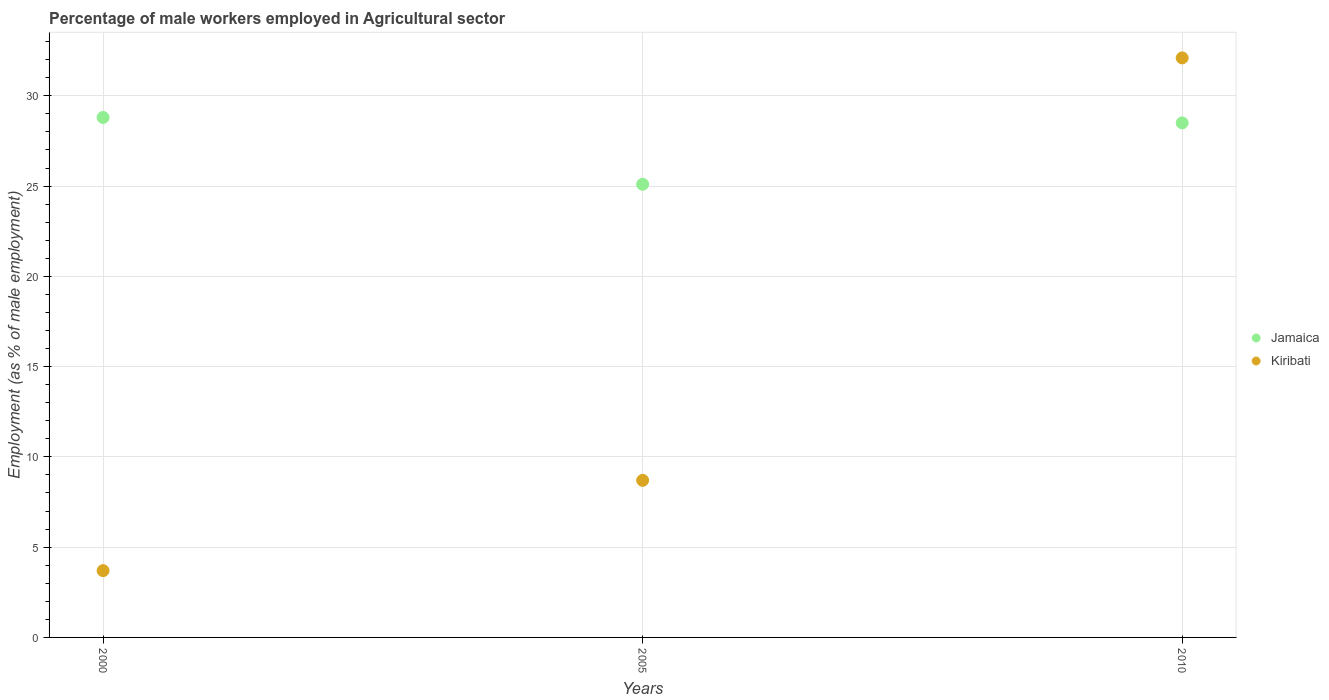Is the number of dotlines equal to the number of legend labels?
Give a very brief answer. Yes. What is the percentage of male workers employed in Agricultural sector in Kiribati in 2005?
Your answer should be compact. 8.7. Across all years, what is the maximum percentage of male workers employed in Agricultural sector in Kiribati?
Your answer should be very brief. 32.1. Across all years, what is the minimum percentage of male workers employed in Agricultural sector in Jamaica?
Your answer should be very brief. 25.1. In which year was the percentage of male workers employed in Agricultural sector in Jamaica maximum?
Provide a short and direct response. 2000. In which year was the percentage of male workers employed in Agricultural sector in Jamaica minimum?
Give a very brief answer. 2005. What is the total percentage of male workers employed in Agricultural sector in Jamaica in the graph?
Provide a short and direct response. 82.4. What is the difference between the percentage of male workers employed in Agricultural sector in Jamaica in 2000 and that in 2005?
Ensure brevity in your answer.  3.7. What is the difference between the percentage of male workers employed in Agricultural sector in Kiribati in 2005 and the percentage of male workers employed in Agricultural sector in Jamaica in 2000?
Offer a very short reply. -20.1. What is the average percentage of male workers employed in Agricultural sector in Kiribati per year?
Provide a short and direct response. 14.83. In the year 2000, what is the difference between the percentage of male workers employed in Agricultural sector in Kiribati and percentage of male workers employed in Agricultural sector in Jamaica?
Offer a very short reply. -25.1. In how many years, is the percentage of male workers employed in Agricultural sector in Kiribati greater than 2 %?
Keep it short and to the point. 3. What is the ratio of the percentage of male workers employed in Agricultural sector in Jamaica in 2000 to that in 2010?
Offer a terse response. 1.01. Is the percentage of male workers employed in Agricultural sector in Jamaica in 2000 less than that in 2005?
Provide a short and direct response. No. Is the difference between the percentage of male workers employed in Agricultural sector in Kiribati in 2005 and 2010 greater than the difference between the percentage of male workers employed in Agricultural sector in Jamaica in 2005 and 2010?
Make the answer very short. No. What is the difference between the highest and the second highest percentage of male workers employed in Agricultural sector in Jamaica?
Offer a very short reply. 0.3. What is the difference between the highest and the lowest percentage of male workers employed in Agricultural sector in Kiribati?
Give a very brief answer. 28.4. Is the percentage of male workers employed in Agricultural sector in Kiribati strictly less than the percentage of male workers employed in Agricultural sector in Jamaica over the years?
Your response must be concise. No. How many dotlines are there?
Keep it short and to the point. 2. What is the title of the graph?
Offer a terse response. Percentage of male workers employed in Agricultural sector. Does "Lebanon" appear as one of the legend labels in the graph?
Your answer should be very brief. No. What is the label or title of the X-axis?
Your answer should be very brief. Years. What is the label or title of the Y-axis?
Provide a short and direct response. Employment (as % of male employment). What is the Employment (as % of male employment) in Jamaica in 2000?
Your response must be concise. 28.8. What is the Employment (as % of male employment) of Kiribati in 2000?
Keep it short and to the point. 3.7. What is the Employment (as % of male employment) in Jamaica in 2005?
Ensure brevity in your answer.  25.1. What is the Employment (as % of male employment) in Kiribati in 2005?
Ensure brevity in your answer.  8.7. What is the Employment (as % of male employment) of Kiribati in 2010?
Your answer should be compact. 32.1. Across all years, what is the maximum Employment (as % of male employment) of Jamaica?
Make the answer very short. 28.8. Across all years, what is the maximum Employment (as % of male employment) of Kiribati?
Ensure brevity in your answer.  32.1. Across all years, what is the minimum Employment (as % of male employment) in Jamaica?
Keep it short and to the point. 25.1. Across all years, what is the minimum Employment (as % of male employment) in Kiribati?
Offer a very short reply. 3.7. What is the total Employment (as % of male employment) of Jamaica in the graph?
Make the answer very short. 82.4. What is the total Employment (as % of male employment) of Kiribati in the graph?
Keep it short and to the point. 44.5. What is the difference between the Employment (as % of male employment) of Jamaica in 2000 and that in 2005?
Your response must be concise. 3.7. What is the difference between the Employment (as % of male employment) in Kiribati in 2000 and that in 2005?
Offer a very short reply. -5. What is the difference between the Employment (as % of male employment) in Kiribati in 2000 and that in 2010?
Your answer should be very brief. -28.4. What is the difference between the Employment (as % of male employment) of Jamaica in 2005 and that in 2010?
Your answer should be compact. -3.4. What is the difference between the Employment (as % of male employment) in Kiribati in 2005 and that in 2010?
Give a very brief answer. -23.4. What is the difference between the Employment (as % of male employment) in Jamaica in 2000 and the Employment (as % of male employment) in Kiribati in 2005?
Your response must be concise. 20.1. What is the difference between the Employment (as % of male employment) of Jamaica in 2005 and the Employment (as % of male employment) of Kiribati in 2010?
Make the answer very short. -7. What is the average Employment (as % of male employment) in Jamaica per year?
Offer a terse response. 27.47. What is the average Employment (as % of male employment) of Kiribati per year?
Keep it short and to the point. 14.83. In the year 2000, what is the difference between the Employment (as % of male employment) in Jamaica and Employment (as % of male employment) in Kiribati?
Provide a succinct answer. 25.1. In the year 2005, what is the difference between the Employment (as % of male employment) in Jamaica and Employment (as % of male employment) in Kiribati?
Offer a terse response. 16.4. What is the ratio of the Employment (as % of male employment) in Jamaica in 2000 to that in 2005?
Ensure brevity in your answer.  1.15. What is the ratio of the Employment (as % of male employment) of Kiribati in 2000 to that in 2005?
Provide a succinct answer. 0.43. What is the ratio of the Employment (as % of male employment) in Jamaica in 2000 to that in 2010?
Provide a short and direct response. 1.01. What is the ratio of the Employment (as % of male employment) of Kiribati in 2000 to that in 2010?
Provide a short and direct response. 0.12. What is the ratio of the Employment (as % of male employment) of Jamaica in 2005 to that in 2010?
Provide a short and direct response. 0.88. What is the ratio of the Employment (as % of male employment) of Kiribati in 2005 to that in 2010?
Give a very brief answer. 0.27. What is the difference between the highest and the second highest Employment (as % of male employment) in Jamaica?
Give a very brief answer. 0.3. What is the difference between the highest and the second highest Employment (as % of male employment) of Kiribati?
Provide a short and direct response. 23.4. What is the difference between the highest and the lowest Employment (as % of male employment) of Kiribati?
Ensure brevity in your answer.  28.4. 